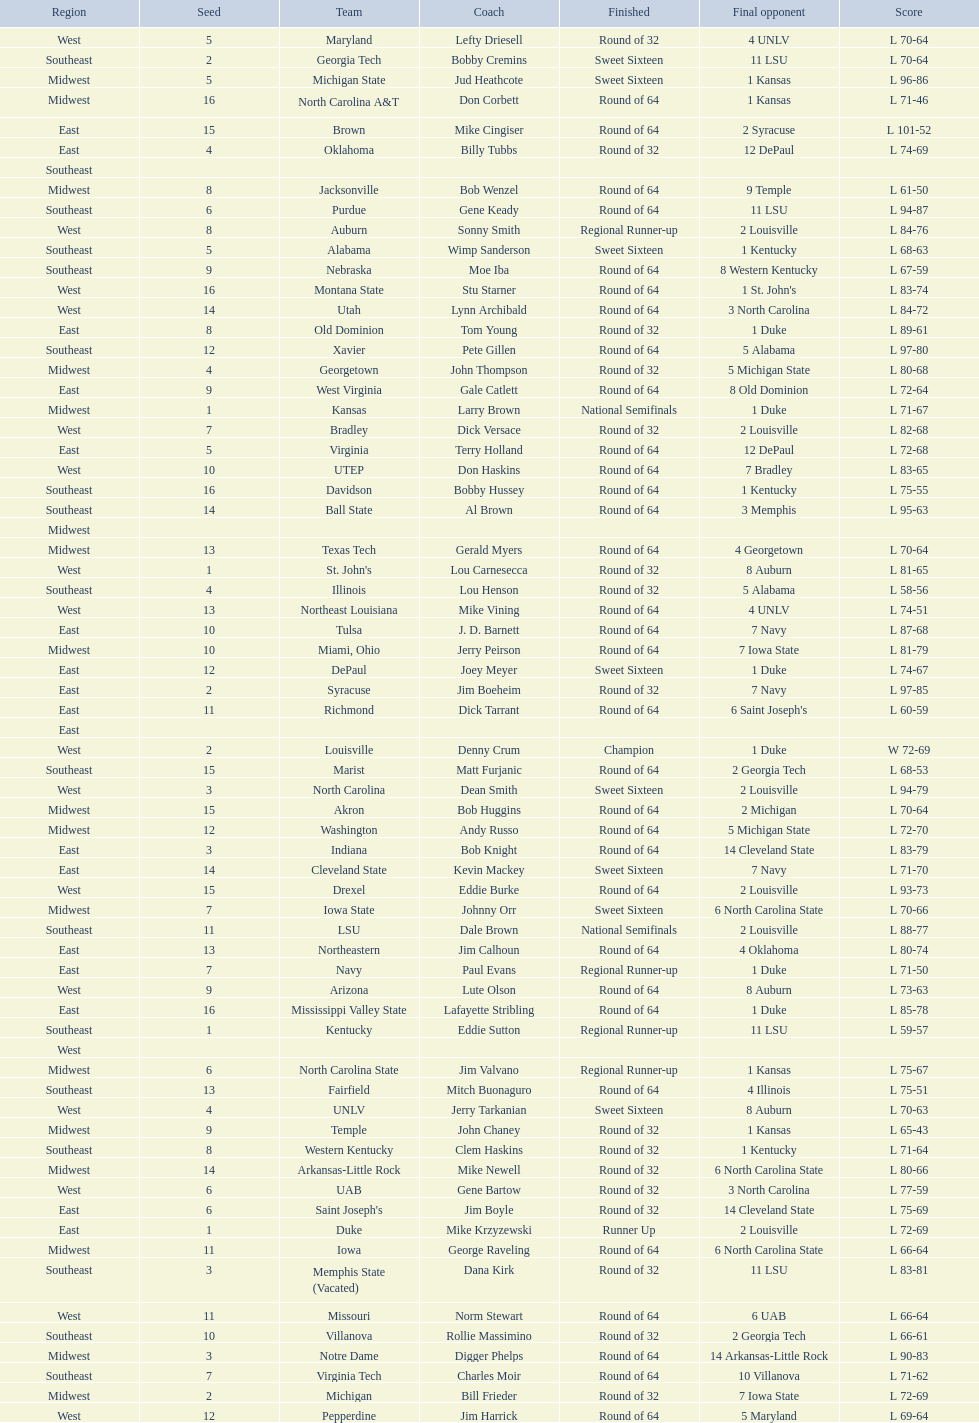How many teams are in the east region. 16. 